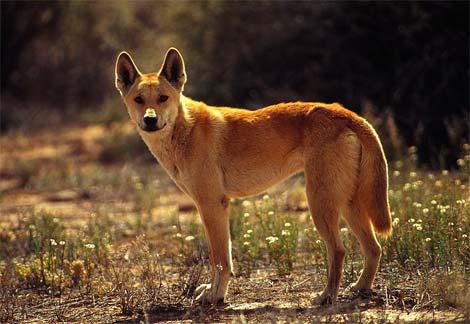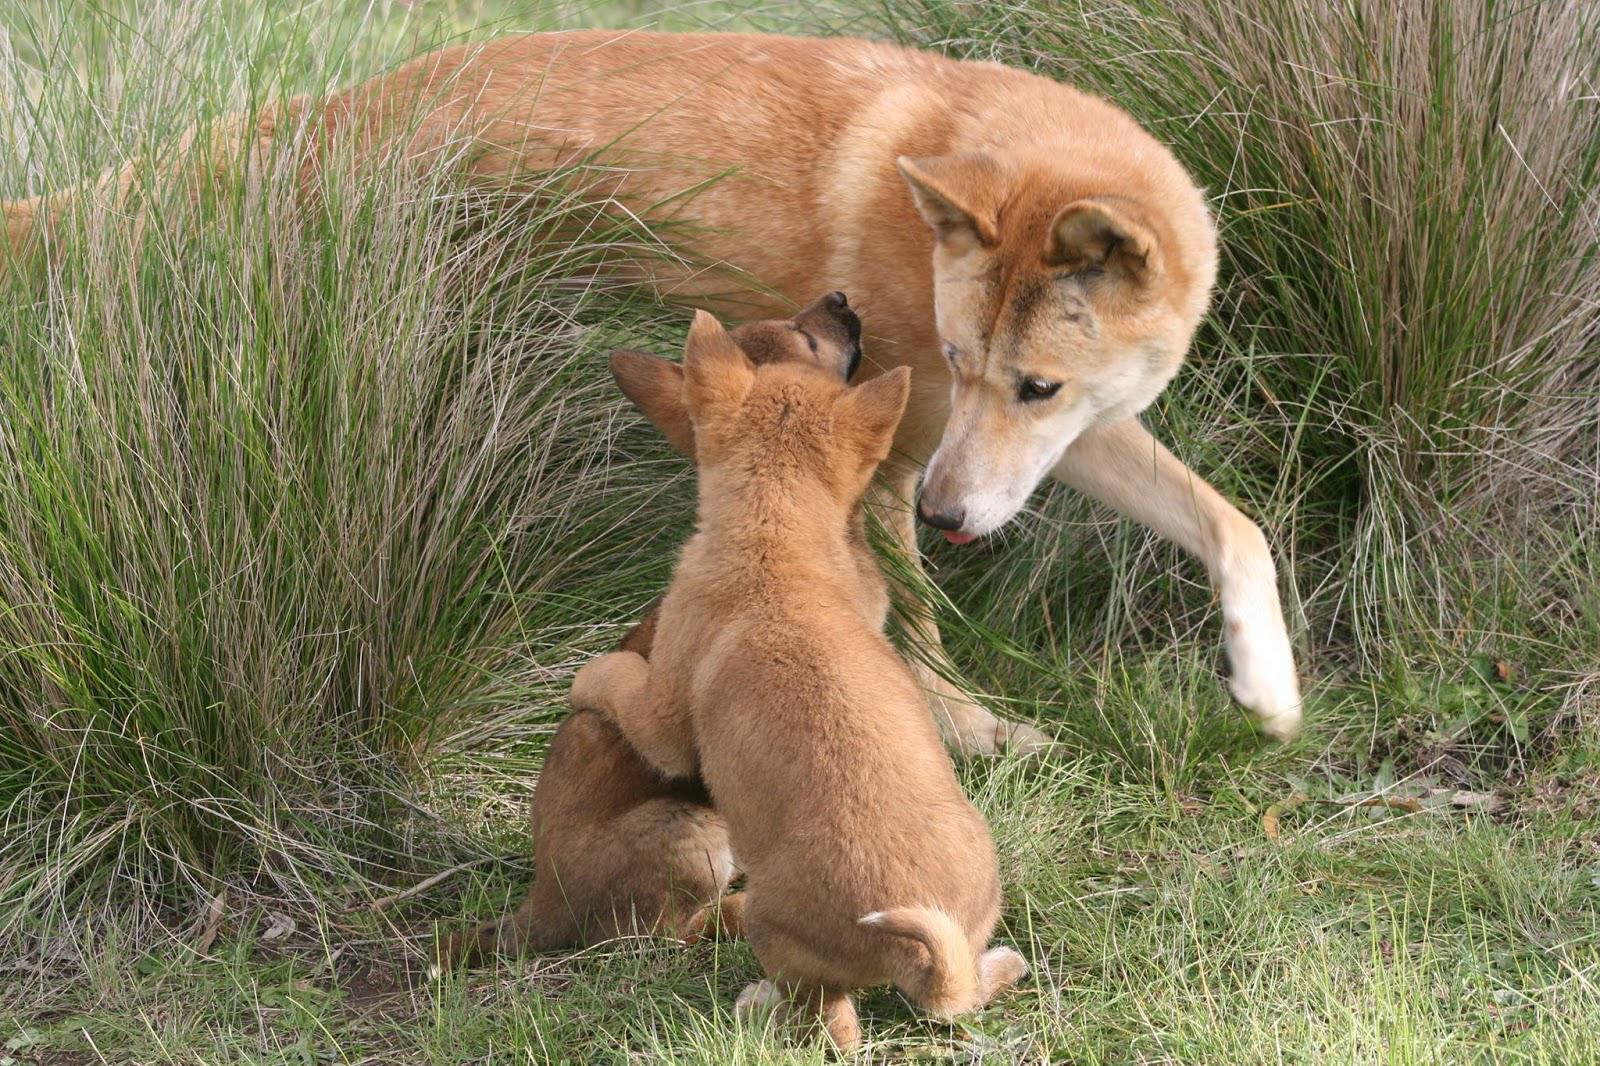The first image is the image on the left, the second image is the image on the right. Analyze the images presented: Is the assertion "The combined images include at least two dingo pups and at least one adult dingo." valid? Answer yes or no. Yes. 